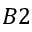Convert formula to latex. <formula><loc_0><loc_0><loc_500><loc_500>B 2</formula> 